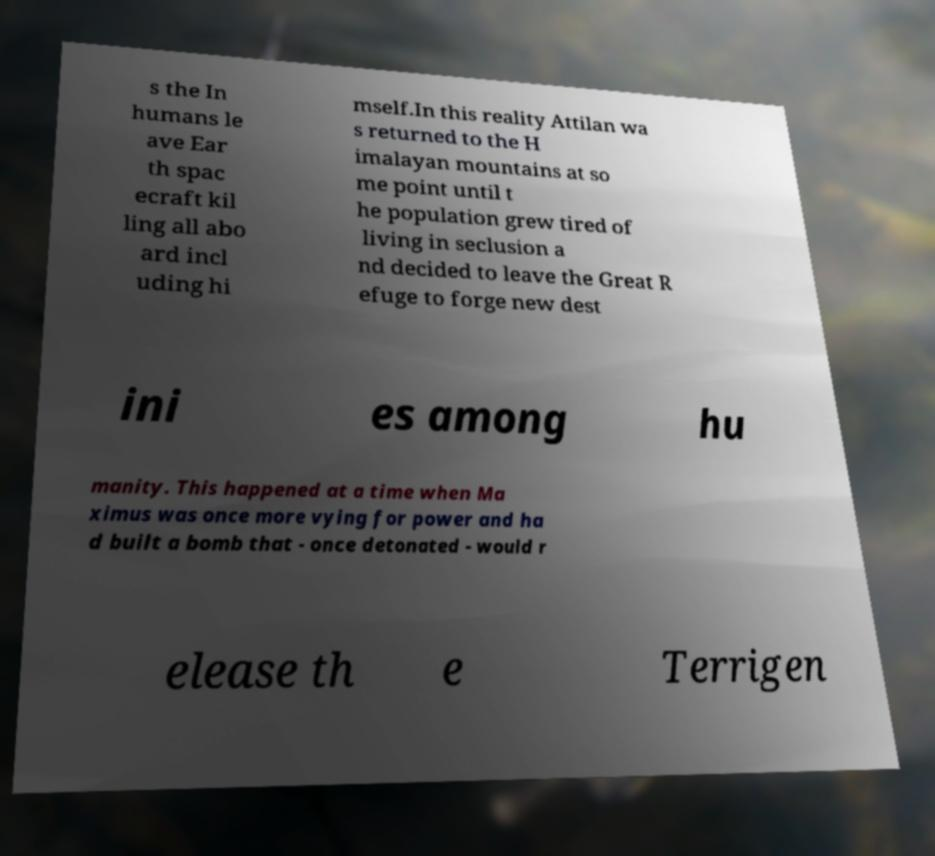What messages or text are displayed in this image? I need them in a readable, typed format. s the In humans le ave Ear th spac ecraft kil ling all abo ard incl uding hi mself.In this reality Attilan wa s returned to the H imalayan mountains at so me point until t he population grew tired of living in seclusion a nd decided to leave the Great R efuge to forge new dest ini es among hu manity. This happened at a time when Ma ximus was once more vying for power and ha d built a bomb that - once detonated - would r elease th e Terrigen 